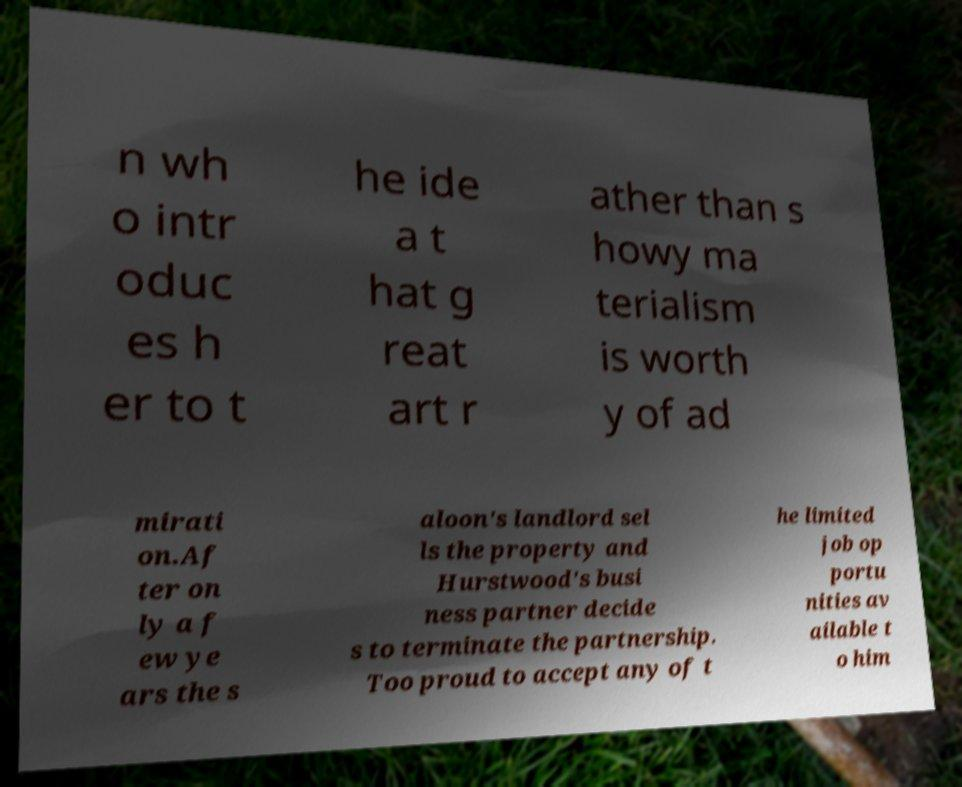Please identify and transcribe the text found in this image. n wh o intr oduc es h er to t he ide a t hat g reat art r ather than s howy ma terialism is worth y of ad mirati on.Af ter on ly a f ew ye ars the s aloon's landlord sel ls the property and Hurstwood's busi ness partner decide s to terminate the partnership. Too proud to accept any of t he limited job op portu nities av ailable t o him 